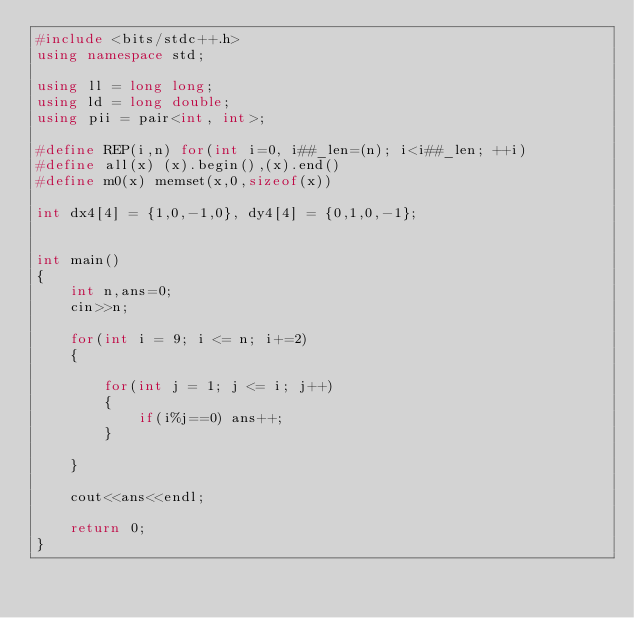<code> <loc_0><loc_0><loc_500><loc_500><_C++_>#include <bits/stdc++.h>
using namespace std;

using ll = long long;
using ld = long double;
using pii = pair<int, int>;

#define REP(i,n) for(int i=0, i##_len=(n); i<i##_len; ++i)
#define all(x) (x).begin(),(x).end()
#define m0(x) memset(x,0,sizeof(x))

int dx4[4] = {1,0,-1,0}, dy4[4] = {0,1,0,-1};


int main()
{
    int n,ans=0;
    cin>>n;
    
    for(int i = 9; i <= n; i+=2)
    {
        
        for(int j = 1; j <= i; j++)
        {
            if(i%j==0) ans++;
        }
        
    }
    
    cout<<ans<<endl;

    return 0;
}</code> 